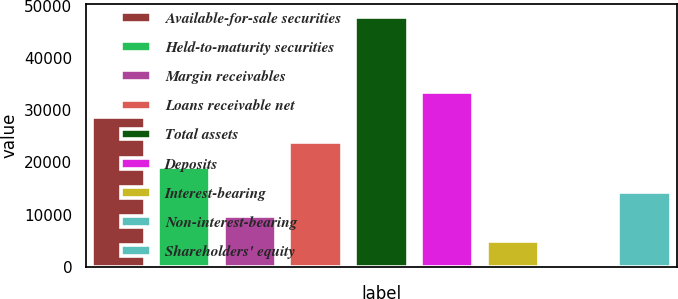Convert chart. <chart><loc_0><loc_0><loc_500><loc_500><bar_chart><fcel>Available-for-sale securities<fcel>Held-to-maturity securities<fcel>Margin receivables<fcel>Loans receivable net<fcel>Total assets<fcel>Deposits<fcel>Interest-bearing<fcel>Non-interest-bearing<fcel>Shareholders' equity<nl><fcel>28781.2<fcel>19201.8<fcel>9622.4<fcel>23991.5<fcel>47940<fcel>33570.9<fcel>4832.7<fcel>43<fcel>14412.1<nl></chart> 